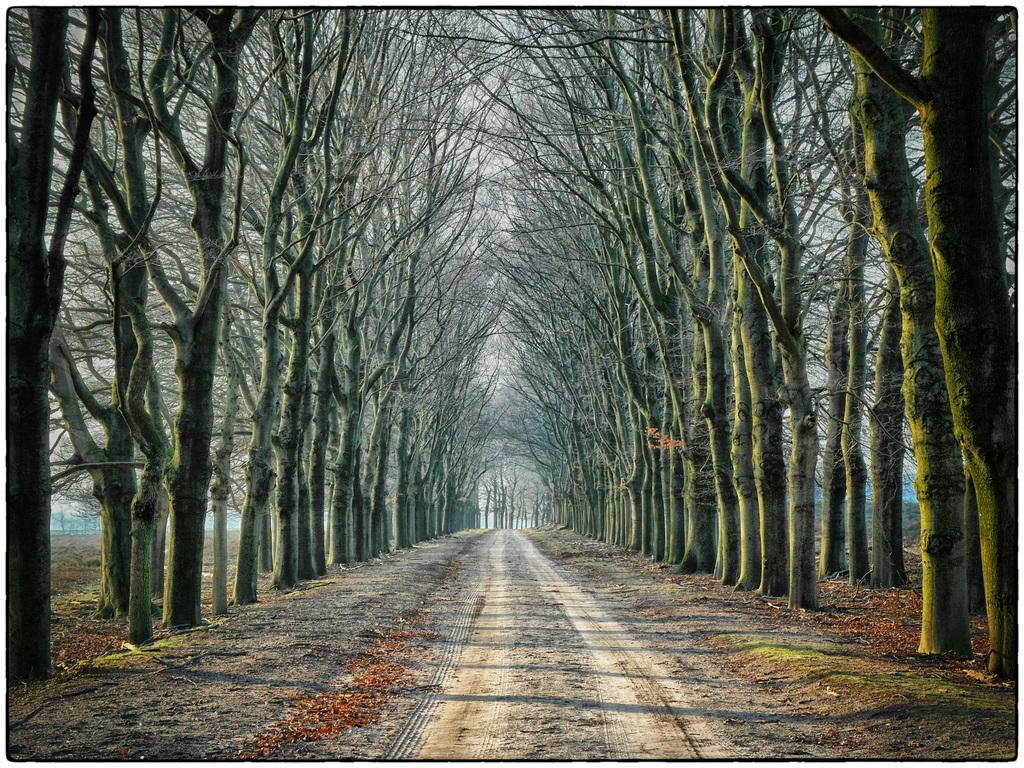Could you give a brief overview of what you see in this image? In this image, we can see trees and at the bottom, there is a road. 